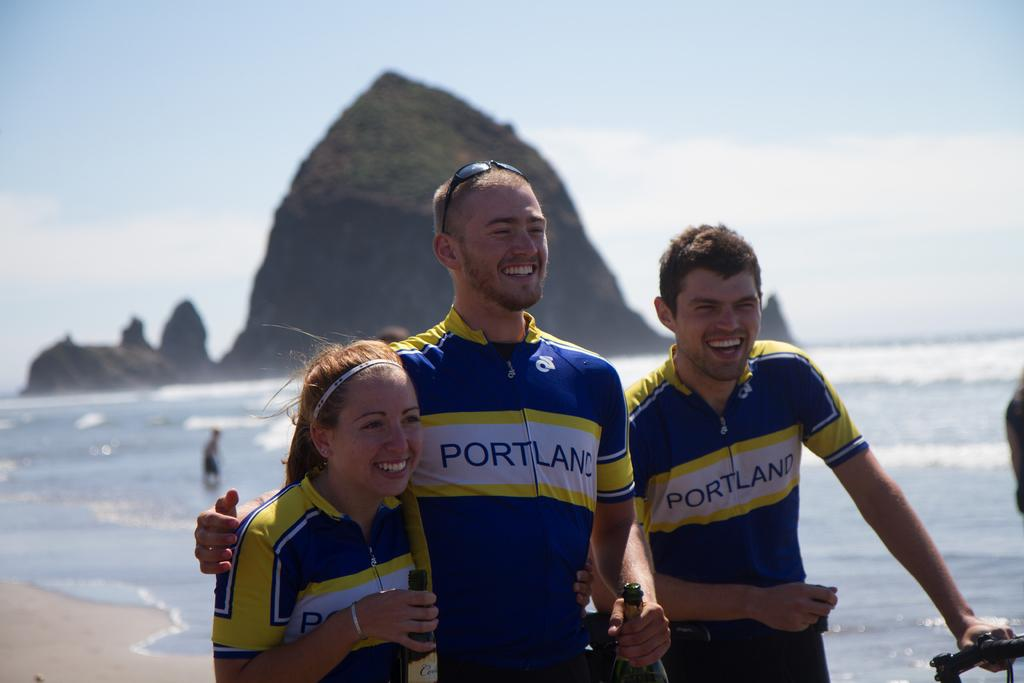Provide a one-sentence caption for the provided image. THREE PEOPLE STANDING ON THE BEACH WITH PORTLAND WRITTEN ON THEIR SHIRTS. 